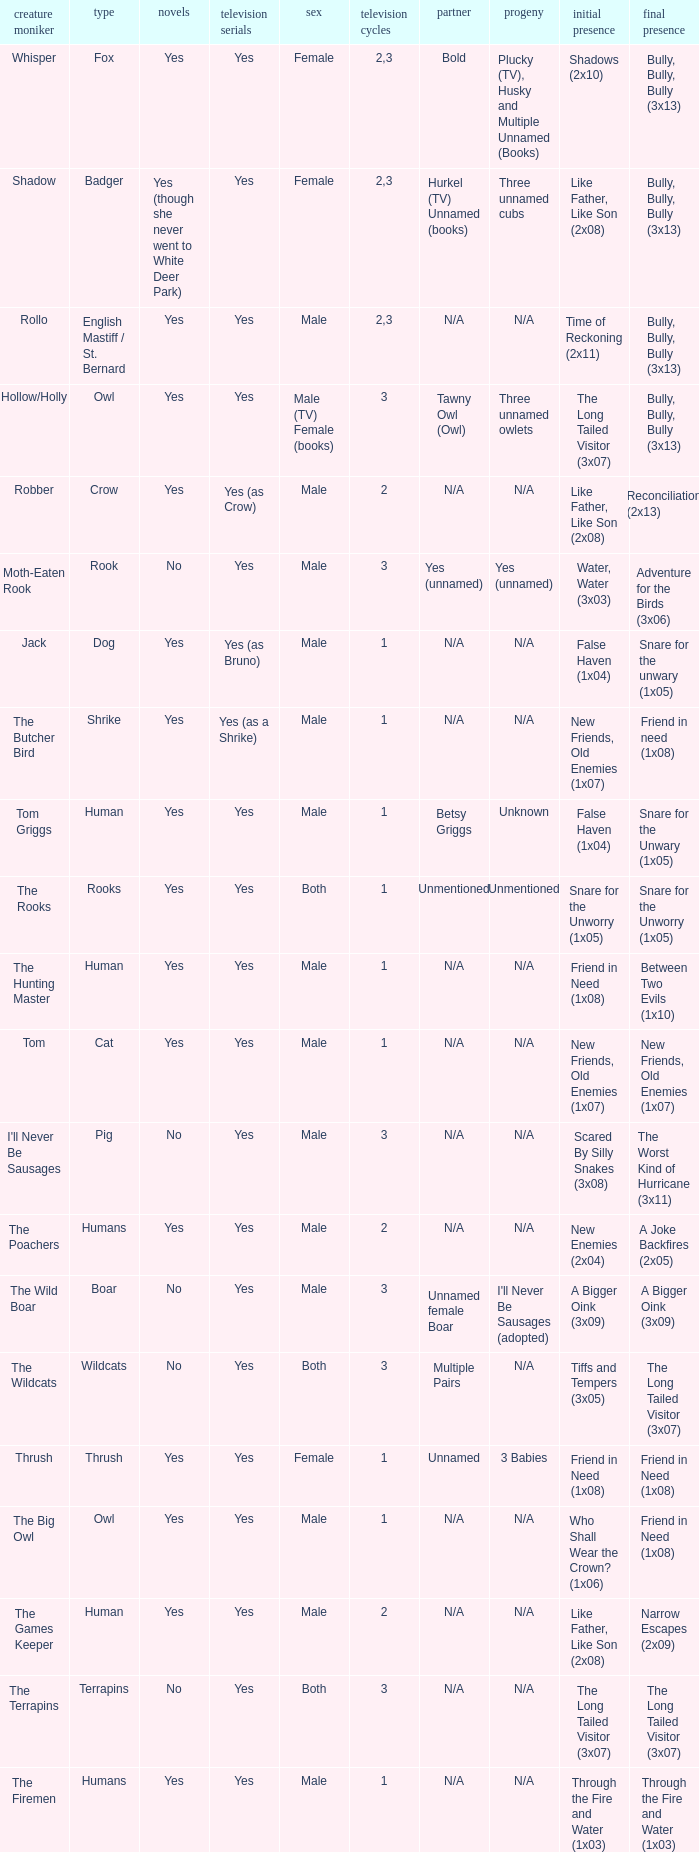What show has a boar? Yes. 